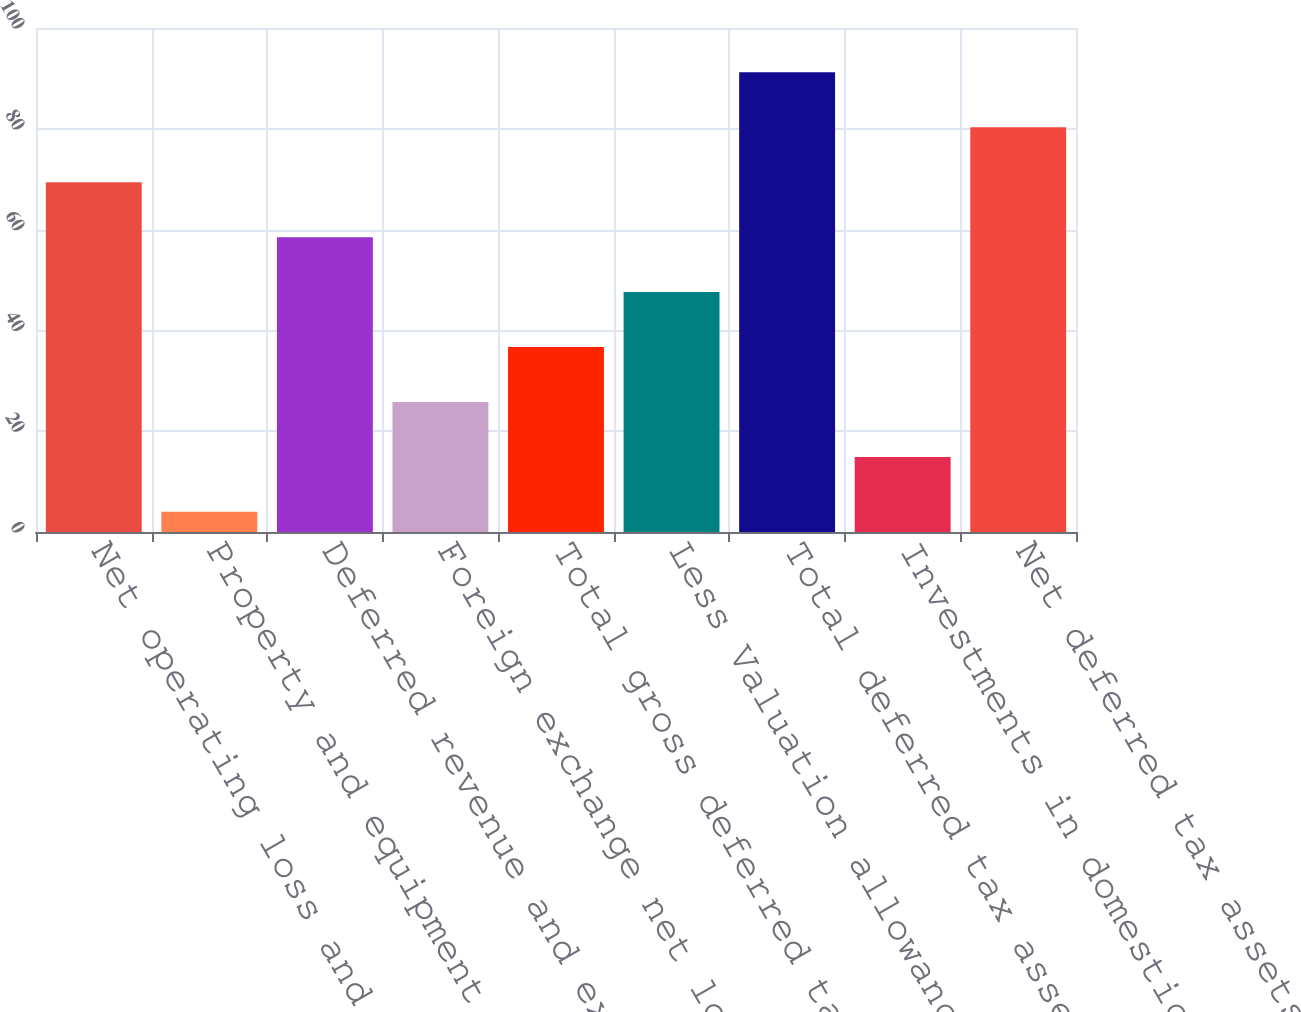Convert chart to OTSL. <chart><loc_0><loc_0><loc_500><loc_500><bar_chart><fcel>Net operating loss and capital<fcel>Property and equipment<fcel>Deferred revenue and expenses<fcel>Foreign exchange net losses<fcel>Total gross deferred tax<fcel>Less Valuation allowance<fcel>Total deferred tax assets net<fcel>Investments in domestic and<fcel>Net deferred tax assets<nl><fcel>69.4<fcel>4<fcel>58.5<fcel>25.8<fcel>36.7<fcel>47.6<fcel>91.2<fcel>14.9<fcel>80.3<nl></chart> 